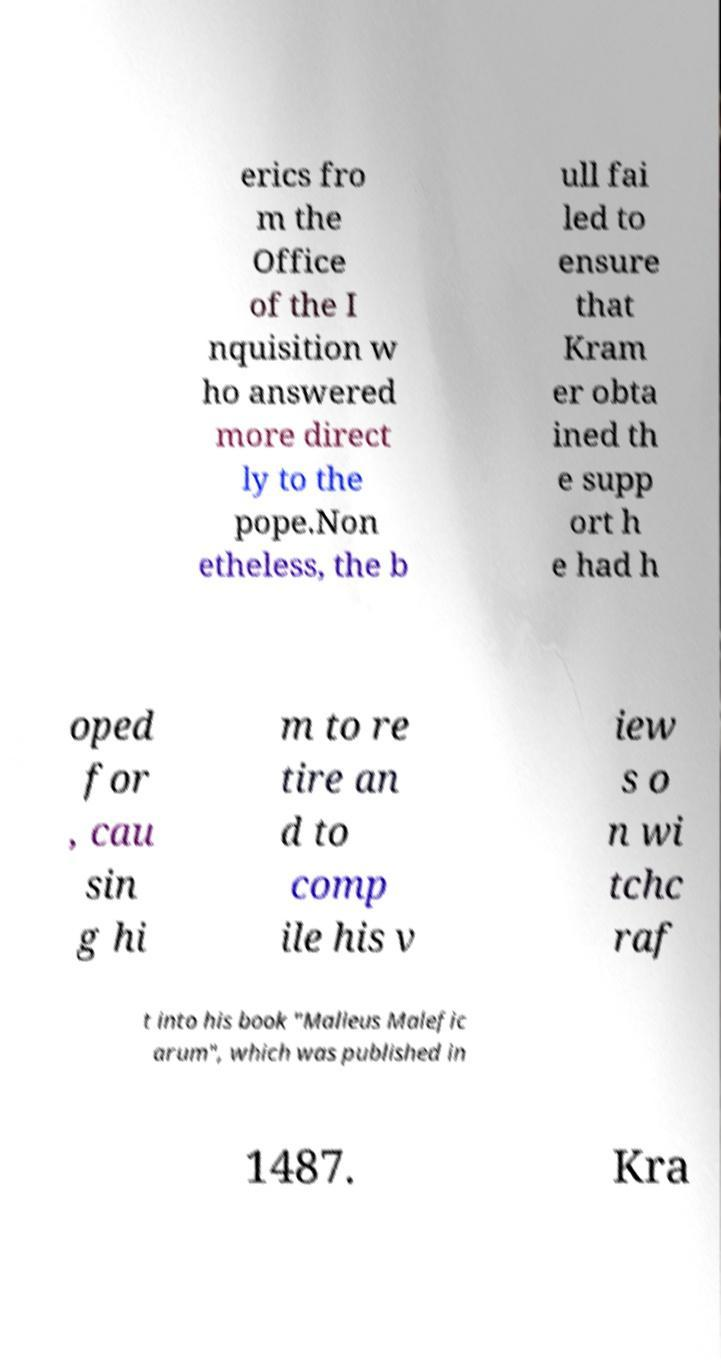For documentation purposes, I need the text within this image transcribed. Could you provide that? erics fro m the Office of the I nquisition w ho answered more direct ly to the pope.Non etheless, the b ull fai led to ensure that Kram er obta ined th e supp ort h e had h oped for , cau sin g hi m to re tire an d to comp ile his v iew s o n wi tchc raf t into his book "Malleus Malefic arum", which was published in 1487. Kra 